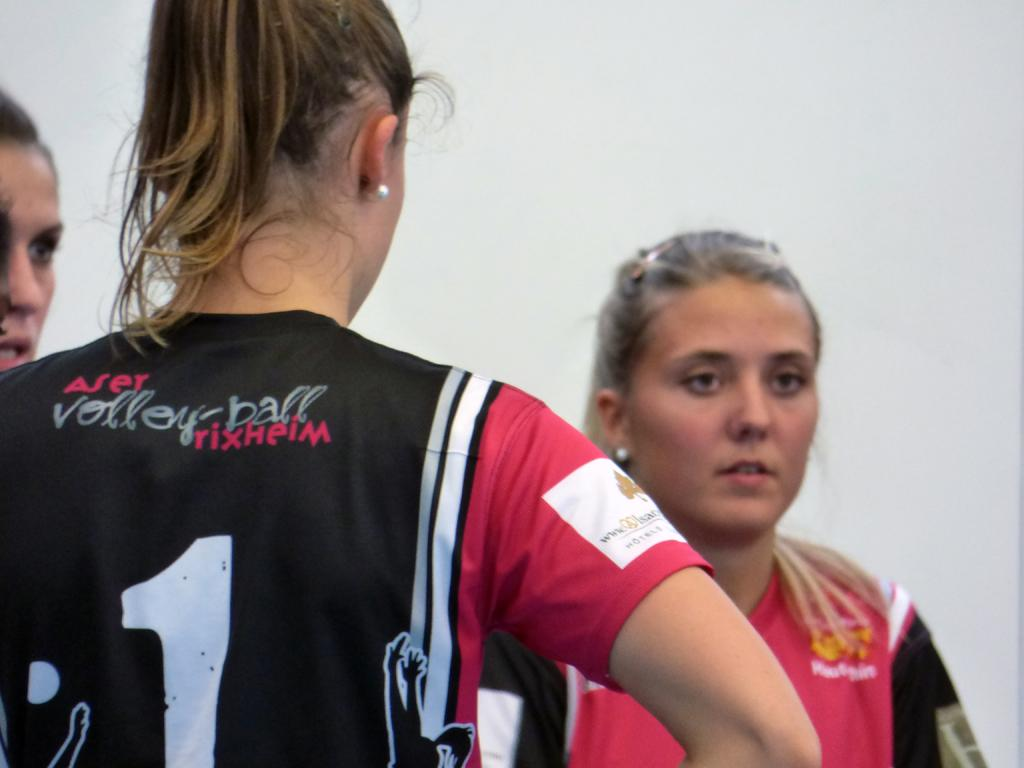<image>
Write a terse but informative summary of the picture. The girls pictured are part of a volley ball team. 